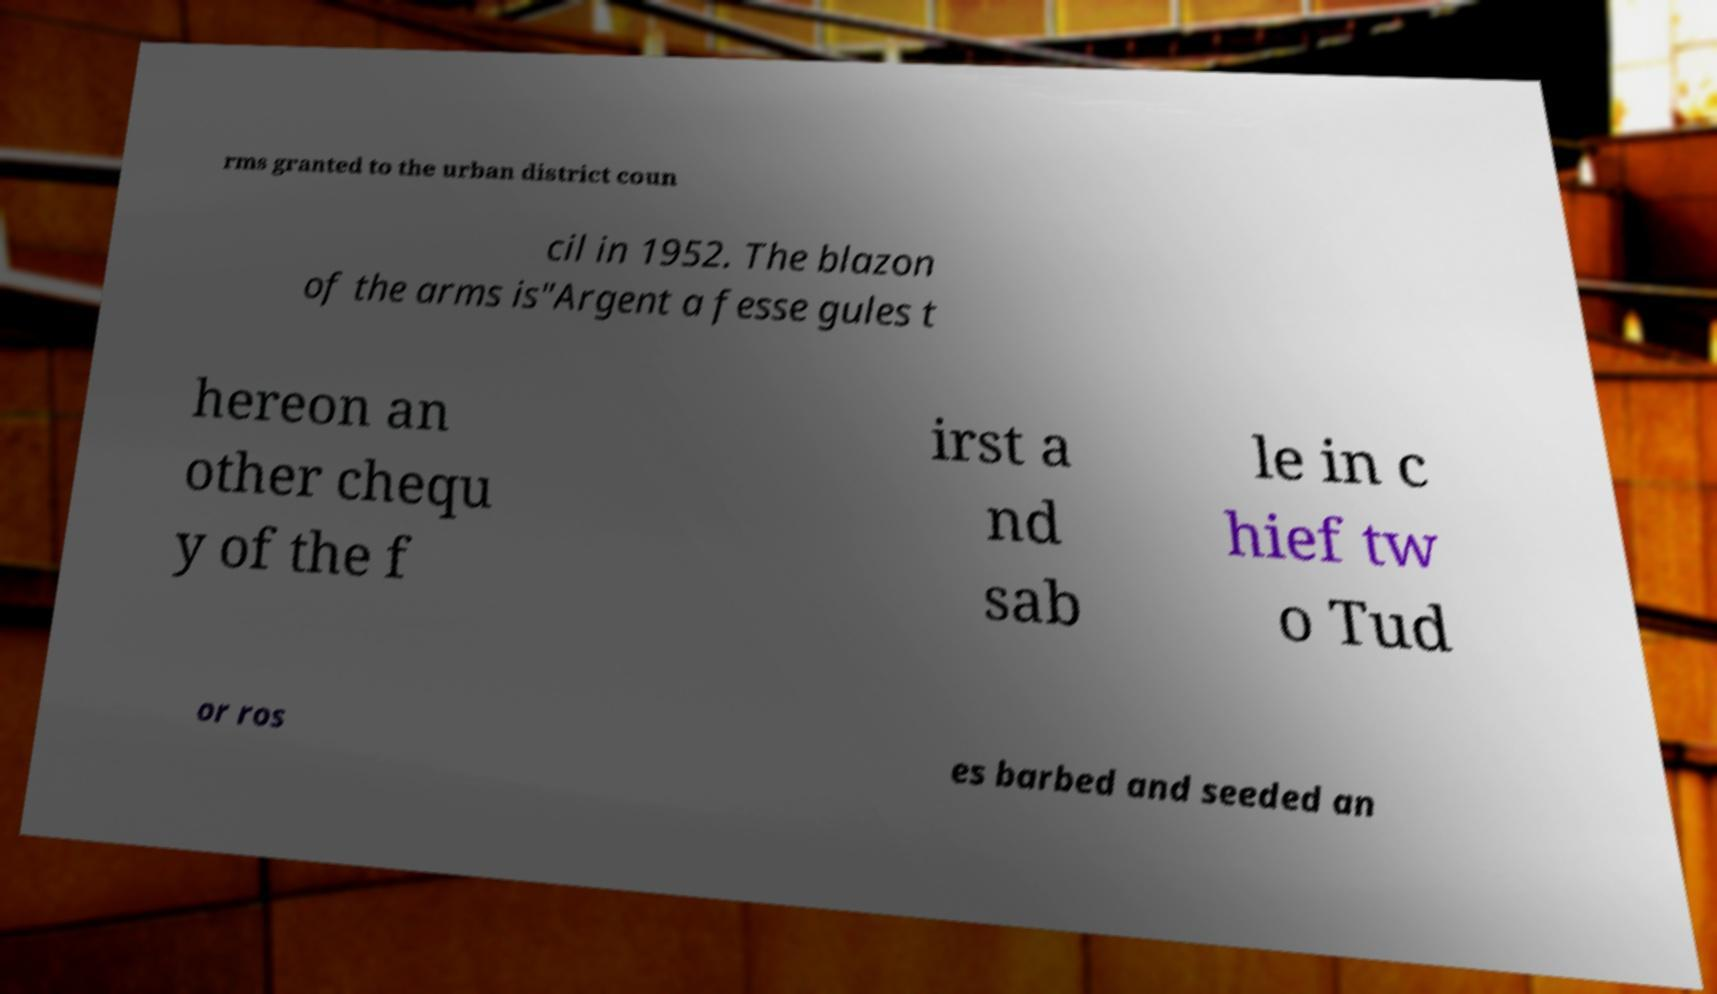Can you accurately transcribe the text from the provided image for me? rms granted to the urban district coun cil in 1952. The blazon of the arms is"Argent a fesse gules t hereon an other chequ y of the f irst a nd sab le in c hief tw o Tud or ros es barbed and seeded an 